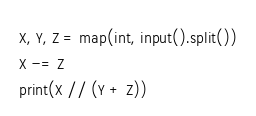Convert code to text. <code><loc_0><loc_0><loc_500><loc_500><_Python_>X, Y, Z = map(int, input().split())
X -= Z
print(X // (Y + Z))</code> 